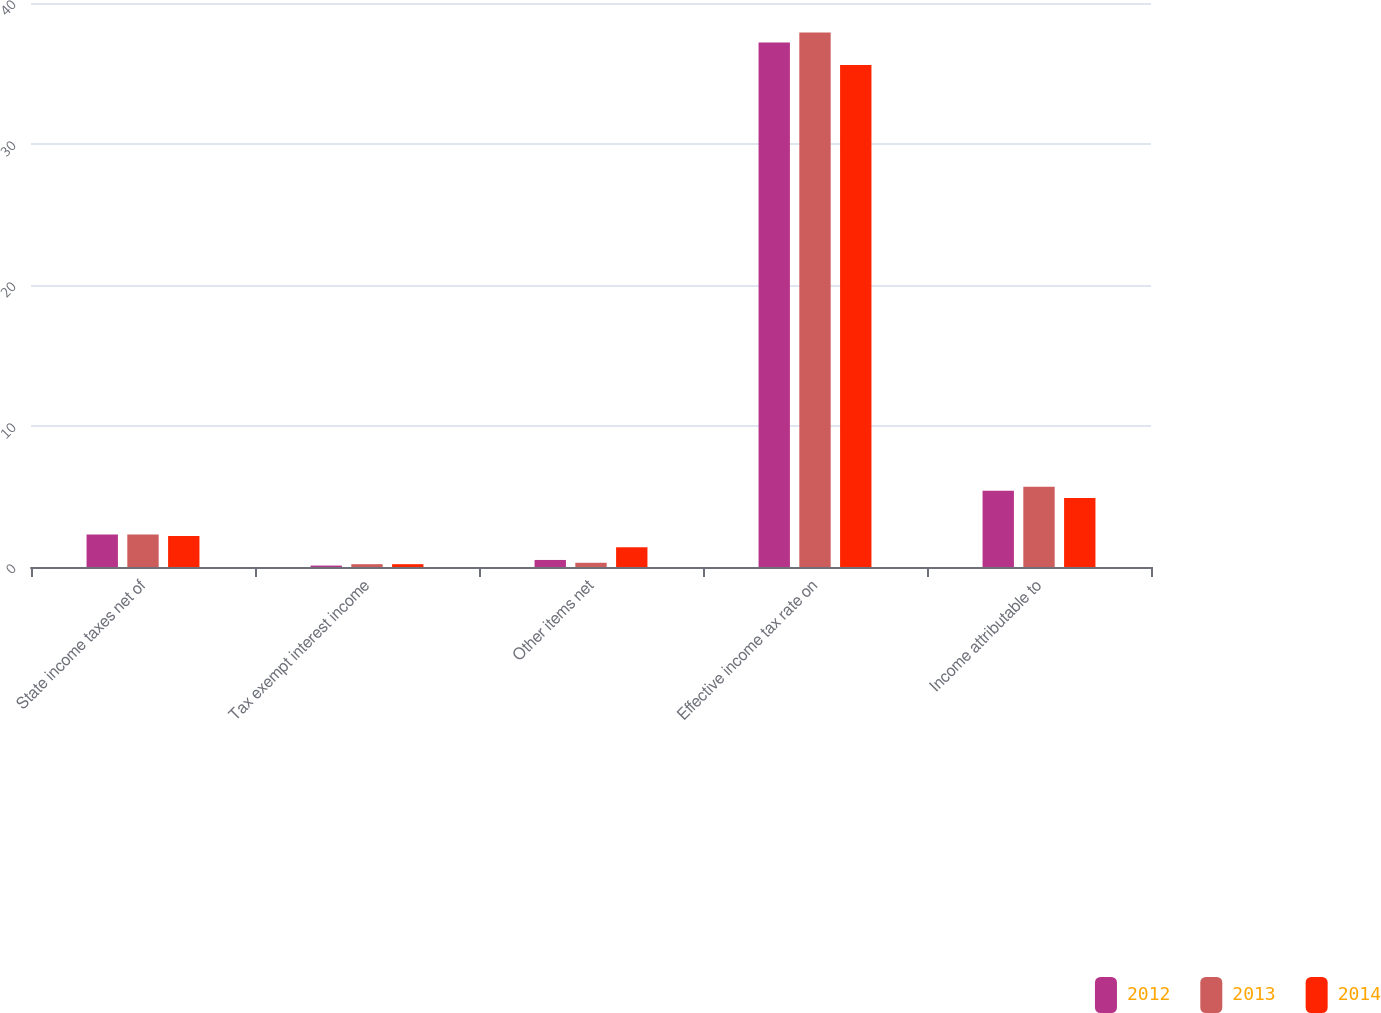Convert chart. <chart><loc_0><loc_0><loc_500><loc_500><stacked_bar_chart><ecel><fcel>State income taxes net of<fcel>Tax exempt interest income<fcel>Other items net<fcel>Effective income tax rate on<fcel>Income attributable to<nl><fcel>2012<fcel>2.3<fcel>0.1<fcel>0.5<fcel>37.2<fcel>5.4<nl><fcel>2013<fcel>2.3<fcel>0.2<fcel>0.3<fcel>37.9<fcel>5.7<nl><fcel>2014<fcel>2.2<fcel>0.2<fcel>1.4<fcel>35.6<fcel>4.9<nl></chart> 